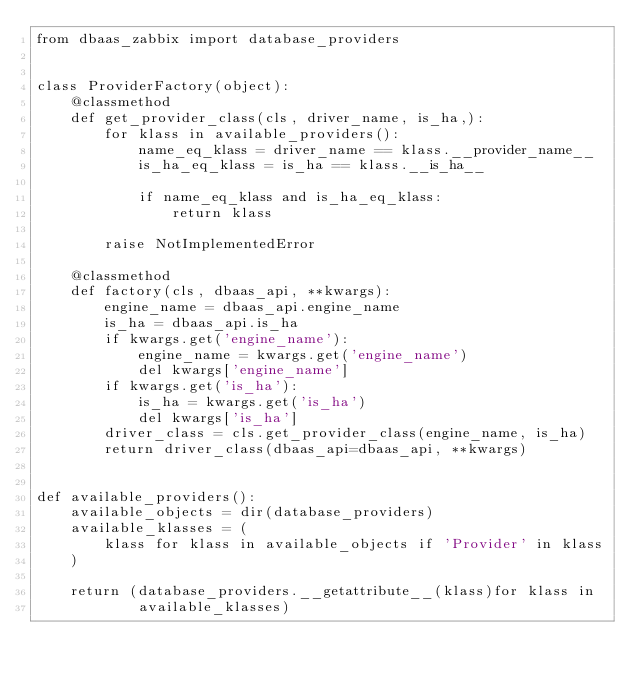<code> <loc_0><loc_0><loc_500><loc_500><_Python_>from dbaas_zabbix import database_providers


class ProviderFactory(object):
    @classmethod
    def get_provider_class(cls, driver_name, is_ha,):
        for klass in available_providers():
            name_eq_klass = driver_name == klass.__provider_name__
            is_ha_eq_klass = is_ha == klass.__is_ha__

            if name_eq_klass and is_ha_eq_klass:
                return klass

        raise NotImplementedError

    @classmethod
    def factory(cls, dbaas_api, **kwargs):
        engine_name = dbaas_api.engine_name
        is_ha = dbaas_api.is_ha
        if kwargs.get('engine_name'):
            engine_name = kwargs.get('engine_name')
            del kwargs['engine_name']
        if kwargs.get('is_ha'):
            is_ha = kwargs.get('is_ha')
            del kwargs['is_ha']
        driver_class = cls.get_provider_class(engine_name, is_ha)
        return driver_class(dbaas_api=dbaas_api, **kwargs)


def available_providers():
    available_objects = dir(database_providers)
    available_klasses = (
        klass for klass in available_objects if 'Provider' in klass
    )

    return (database_providers.__getattribute__(klass)for klass in
            available_klasses)
</code> 